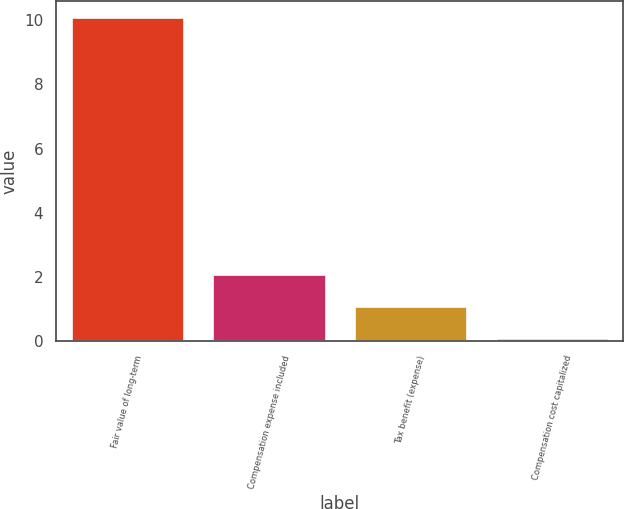Convert chart. <chart><loc_0><loc_0><loc_500><loc_500><bar_chart><fcel>Fair value of long-term<fcel>Compensation expense included<fcel>Tax benefit (expense)<fcel>Compensation cost capitalized<nl><fcel>10.1<fcel>2.1<fcel>1.1<fcel>0.1<nl></chart> 